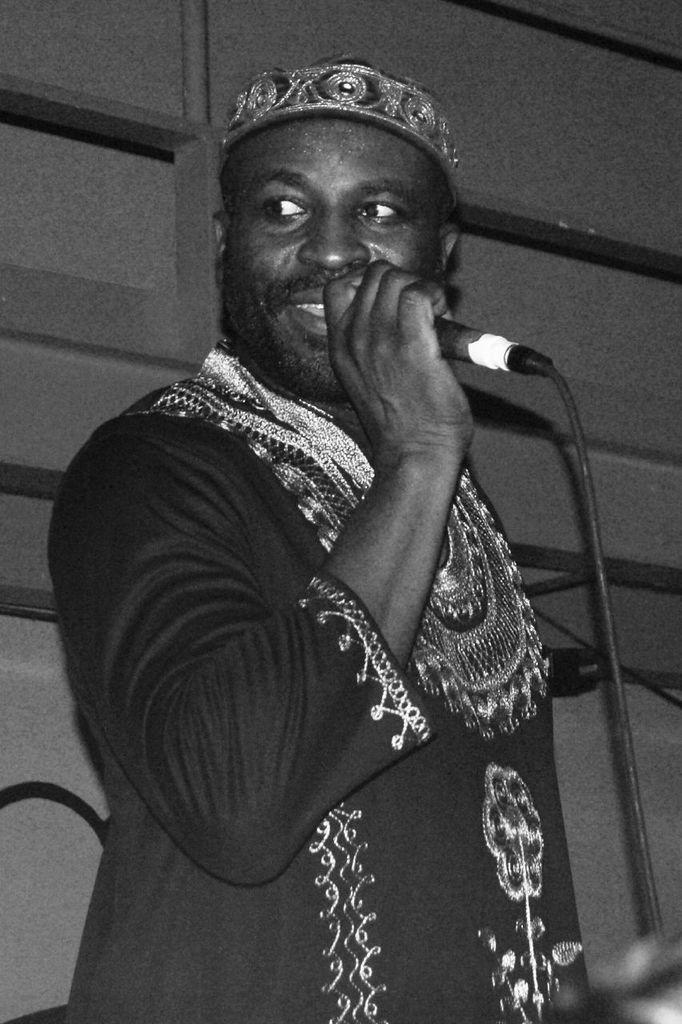What is the main subject of the image? The main subject of the image is a guy. What is the guy holding in his hand? The guy is holding a mic in his hand. Can you describe the guy's attire? The guy is wearing a decorated dress. How many cars are parked behind the guy in the image? There are no cars visible in the image; it only features a guy holding a mic and wearing a decorated dress. 